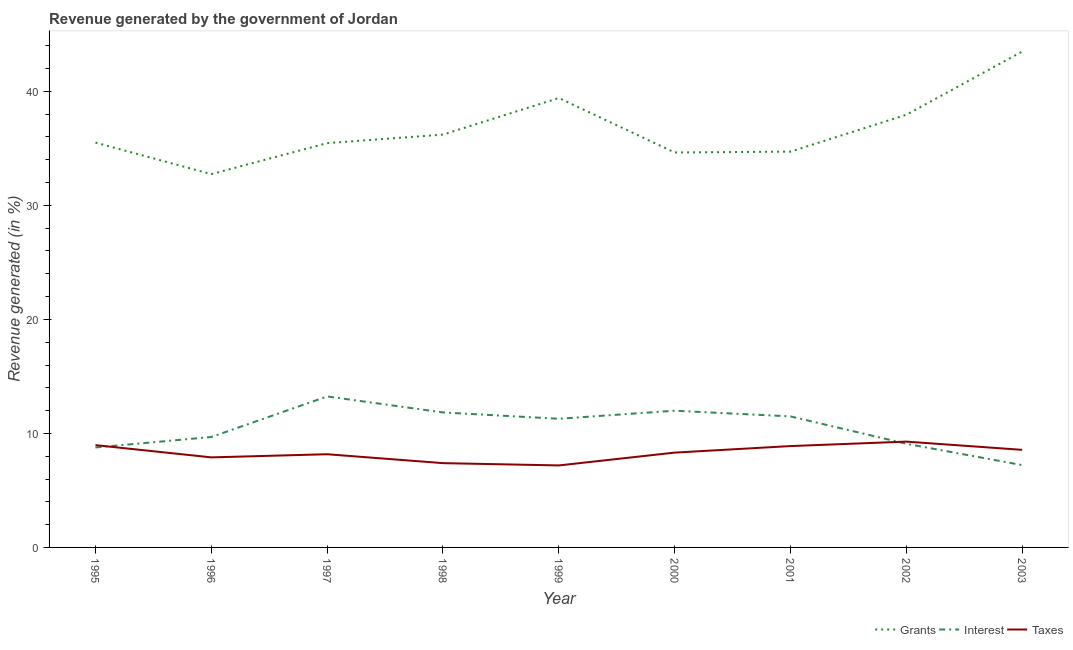What is the percentage of revenue generated by taxes in 1995?
Offer a very short reply. 8.97. Across all years, what is the maximum percentage of revenue generated by grants?
Offer a terse response. 43.49. Across all years, what is the minimum percentage of revenue generated by taxes?
Provide a succinct answer. 7.19. In which year was the percentage of revenue generated by grants maximum?
Offer a terse response. 2003. In which year was the percentage of revenue generated by taxes minimum?
Provide a succinct answer. 1999. What is the total percentage of revenue generated by grants in the graph?
Offer a terse response. 330.13. What is the difference between the percentage of revenue generated by grants in 1996 and that in 2003?
Give a very brief answer. -10.75. What is the difference between the percentage of revenue generated by taxes in 1999 and the percentage of revenue generated by grants in 1995?
Ensure brevity in your answer.  -28.31. What is the average percentage of revenue generated by interest per year?
Ensure brevity in your answer.  10.51. In the year 2001, what is the difference between the percentage of revenue generated by taxes and percentage of revenue generated by grants?
Your answer should be compact. -25.83. In how many years, is the percentage of revenue generated by interest greater than 24 %?
Offer a very short reply. 0. What is the ratio of the percentage of revenue generated by interest in 1998 to that in 2002?
Make the answer very short. 1.3. Is the percentage of revenue generated by interest in 1995 less than that in 1997?
Keep it short and to the point. Yes. What is the difference between the highest and the second highest percentage of revenue generated by interest?
Your response must be concise. 1.25. What is the difference between the highest and the lowest percentage of revenue generated by taxes?
Provide a short and direct response. 2.09. Is it the case that in every year, the sum of the percentage of revenue generated by grants and percentage of revenue generated by interest is greater than the percentage of revenue generated by taxes?
Offer a terse response. Yes. Does the percentage of revenue generated by grants monotonically increase over the years?
Make the answer very short. No. Is the percentage of revenue generated by interest strictly less than the percentage of revenue generated by grants over the years?
Your response must be concise. Yes. What is the difference between two consecutive major ticks on the Y-axis?
Provide a short and direct response. 10. Where does the legend appear in the graph?
Offer a terse response. Bottom right. How are the legend labels stacked?
Keep it short and to the point. Horizontal. What is the title of the graph?
Your response must be concise. Revenue generated by the government of Jordan. What is the label or title of the Y-axis?
Give a very brief answer. Revenue generated (in %). What is the Revenue generated (in %) in Grants in 1995?
Make the answer very short. 35.51. What is the Revenue generated (in %) in Interest in 1995?
Your response must be concise. 8.77. What is the Revenue generated (in %) in Taxes in 1995?
Give a very brief answer. 8.97. What is the Revenue generated (in %) in Grants in 1996?
Your answer should be compact. 32.74. What is the Revenue generated (in %) in Interest in 1996?
Make the answer very short. 9.68. What is the Revenue generated (in %) of Taxes in 1996?
Your answer should be very brief. 7.9. What is the Revenue generated (in %) of Grants in 1997?
Make the answer very short. 35.46. What is the Revenue generated (in %) of Interest in 1997?
Make the answer very short. 13.24. What is the Revenue generated (in %) of Taxes in 1997?
Provide a succinct answer. 8.17. What is the Revenue generated (in %) in Grants in 1998?
Provide a succinct answer. 36.21. What is the Revenue generated (in %) in Interest in 1998?
Keep it short and to the point. 11.84. What is the Revenue generated (in %) of Taxes in 1998?
Make the answer very short. 7.39. What is the Revenue generated (in %) of Grants in 1999?
Provide a succinct answer. 39.42. What is the Revenue generated (in %) of Interest in 1999?
Provide a short and direct response. 11.28. What is the Revenue generated (in %) in Taxes in 1999?
Offer a terse response. 7.19. What is the Revenue generated (in %) in Grants in 2000?
Keep it short and to the point. 34.64. What is the Revenue generated (in %) of Interest in 2000?
Provide a succinct answer. 11.99. What is the Revenue generated (in %) in Taxes in 2000?
Ensure brevity in your answer.  8.32. What is the Revenue generated (in %) in Grants in 2001?
Offer a terse response. 34.71. What is the Revenue generated (in %) in Interest in 2001?
Your answer should be very brief. 11.49. What is the Revenue generated (in %) of Taxes in 2001?
Offer a terse response. 8.89. What is the Revenue generated (in %) in Grants in 2002?
Offer a terse response. 37.95. What is the Revenue generated (in %) in Interest in 2002?
Provide a succinct answer. 9.09. What is the Revenue generated (in %) of Taxes in 2002?
Your answer should be compact. 9.28. What is the Revenue generated (in %) in Grants in 2003?
Your answer should be compact. 43.49. What is the Revenue generated (in %) of Interest in 2003?
Make the answer very short. 7.22. What is the Revenue generated (in %) of Taxes in 2003?
Your answer should be compact. 8.56. Across all years, what is the maximum Revenue generated (in %) in Grants?
Your response must be concise. 43.49. Across all years, what is the maximum Revenue generated (in %) of Interest?
Keep it short and to the point. 13.24. Across all years, what is the maximum Revenue generated (in %) of Taxes?
Your answer should be compact. 9.28. Across all years, what is the minimum Revenue generated (in %) in Grants?
Provide a succinct answer. 32.74. Across all years, what is the minimum Revenue generated (in %) of Interest?
Make the answer very short. 7.22. Across all years, what is the minimum Revenue generated (in %) in Taxes?
Provide a short and direct response. 7.19. What is the total Revenue generated (in %) of Grants in the graph?
Your response must be concise. 330.13. What is the total Revenue generated (in %) of Interest in the graph?
Your answer should be compact. 94.61. What is the total Revenue generated (in %) in Taxes in the graph?
Ensure brevity in your answer.  74.67. What is the difference between the Revenue generated (in %) of Grants in 1995 and that in 1996?
Your answer should be compact. 2.76. What is the difference between the Revenue generated (in %) of Interest in 1995 and that in 1996?
Ensure brevity in your answer.  -0.92. What is the difference between the Revenue generated (in %) in Taxes in 1995 and that in 1996?
Your response must be concise. 1.07. What is the difference between the Revenue generated (in %) in Grants in 1995 and that in 1997?
Your answer should be very brief. 0.05. What is the difference between the Revenue generated (in %) of Interest in 1995 and that in 1997?
Provide a short and direct response. -4.48. What is the difference between the Revenue generated (in %) in Taxes in 1995 and that in 1997?
Keep it short and to the point. 0.8. What is the difference between the Revenue generated (in %) of Grants in 1995 and that in 1998?
Your answer should be very brief. -0.7. What is the difference between the Revenue generated (in %) in Interest in 1995 and that in 1998?
Make the answer very short. -3.07. What is the difference between the Revenue generated (in %) of Taxes in 1995 and that in 1998?
Provide a succinct answer. 1.58. What is the difference between the Revenue generated (in %) in Grants in 1995 and that in 1999?
Your answer should be compact. -3.91. What is the difference between the Revenue generated (in %) in Interest in 1995 and that in 1999?
Provide a succinct answer. -2.52. What is the difference between the Revenue generated (in %) of Taxes in 1995 and that in 1999?
Keep it short and to the point. 1.78. What is the difference between the Revenue generated (in %) in Grants in 1995 and that in 2000?
Give a very brief answer. 0.87. What is the difference between the Revenue generated (in %) of Interest in 1995 and that in 2000?
Give a very brief answer. -3.23. What is the difference between the Revenue generated (in %) of Taxes in 1995 and that in 2000?
Provide a succinct answer. 0.66. What is the difference between the Revenue generated (in %) in Grants in 1995 and that in 2001?
Provide a short and direct response. 0.79. What is the difference between the Revenue generated (in %) in Interest in 1995 and that in 2001?
Your answer should be very brief. -2.73. What is the difference between the Revenue generated (in %) in Taxes in 1995 and that in 2001?
Offer a terse response. 0.08. What is the difference between the Revenue generated (in %) in Grants in 1995 and that in 2002?
Keep it short and to the point. -2.44. What is the difference between the Revenue generated (in %) in Interest in 1995 and that in 2002?
Your answer should be very brief. -0.33. What is the difference between the Revenue generated (in %) of Taxes in 1995 and that in 2002?
Provide a succinct answer. -0.31. What is the difference between the Revenue generated (in %) in Grants in 1995 and that in 2003?
Keep it short and to the point. -7.99. What is the difference between the Revenue generated (in %) in Interest in 1995 and that in 2003?
Give a very brief answer. 1.54. What is the difference between the Revenue generated (in %) of Taxes in 1995 and that in 2003?
Your response must be concise. 0.41. What is the difference between the Revenue generated (in %) of Grants in 1996 and that in 1997?
Ensure brevity in your answer.  -2.72. What is the difference between the Revenue generated (in %) in Interest in 1996 and that in 1997?
Ensure brevity in your answer.  -3.56. What is the difference between the Revenue generated (in %) in Taxes in 1996 and that in 1997?
Provide a short and direct response. -0.28. What is the difference between the Revenue generated (in %) in Grants in 1996 and that in 1998?
Your answer should be compact. -3.47. What is the difference between the Revenue generated (in %) in Interest in 1996 and that in 1998?
Give a very brief answer. -2.15. What is the difference between the Revenue generated (in %) in Taxes in 1996 and that in 1998?
Your answer should be compact. 0.51. What is the difference between the Revenue generated (in %) in Grants in 1996 and that in 1999?
Give a very brief answer. -6.68. What is the difference between the Revenue generated (in %) in Interest in 1996 and that in 1999?
Make the answer very short. -1.6. What is the difference between the Revenue generated (in %) of Taxes in 1996 and that in 1999?
Provide a short and direct response. 0.71. What is the difference between the Revenue generated (in %) in Grants in 1996 and that in 2000?
Offer a very short reply. -1.9. What is the difference between the Revenue generated (in %) in Interest in 1996 and that in 2000?
Ensure brevity in your answer.  -2.31. What is the difference between the Revenue generated (in %) in Taxes in 1996 and that in 2000?
Provide a short and direct response. -0.42. What is the difference between the Revenue generated (in %) in Grants in 1996 and that in 2001?
Your answer should be compact. -1.97. What is the difference between the Revenue generated (in %) in Interest in 1996 and that in 2001?
Your answer should be compact. -1.81. What is the difference between the Revenue generated (in %) in Taxes in 1996 and that in 2001?
Provide a succinct answer. -0.99. What is the difference between the Revenue generated (in %) of Grants in 1996 and that in 2002?
Your answer should be very brief. -5.2. What is the difference between the Revenue generated (in %) of Interest in 1996 and that in 2002?
Your answer should be very brief. 0.59. What is the difference between the Revenue generated (in %) of Taxes in 1996 and that in 2002?
Make the answer very short. -1.38. What is the difference between the Revenue generated (in %) of Grants in 1996 and that in 2003?
Your answer should be very brief. -10.75. What is the difference between the Revenue generated (in %) in Interest in 1996 and that in 2003?
Provide a succinct answer. 2.46. What is the difference between the Revenue generated (in %) in Taxes in 1996 and that in 2003?
Your answer should be compact. -0.66. What is the difference between the Revenue generated (in %) in Grants in 1997 and that in 1998?
Keep it short and to the point. -0.75. What is the difference between the Revenue generated (in %) in Interest in 1997 and that in 1998?
Provide a short and direct response. 1.4. What is the difference between the Revenue generated (in %) in Taxes in 1997 and that in 1998?
Provide a short and direct response. 0.78. What is the difference between the Revenue generated (in %) in Grants in 1997 and that in 1999?
Offer a terse response. -3.96. What is the difference between the Revenue generated (in %) in Interest in 1997 and that in 1999?
Your answer should be very brief. 1.96. What is the difference between the Revenue generated (in %) of Taxes in 1997 and that in 1999?
Your answer should be very brief. 0.98. What is the difference between the Revenue generated (in %) of Grants in 1997 and that in 2000?
Your response must be concise. 0.82. What is the difference between the Revenue generated (in %) of Interest in 1997 and that in 2000?
Provide a succinct answer. 1.25. What is the difference between the Revenue generated (in %) in Taxes in 1997 and that in 2000?
Make the answer very short. -0.14. What is the difference between the Revenue generated (in %) in Grants in 1997 and that in 2001?
Your response must be concise. 0.74. What is the difference between the Revenue generated (in %) in Interest in 1997 and that in 2001?
Ensure brevity in your answer.  1.75. What is the difference between the Revenue generated (in %) in Taxes in 1997 and that in 2001?
Make the answer very short. -0.72. What is the difference between the Revenue generated (in %) of Grants in 1997 and that in 2002?
Offer a terse response. -2.49. What is the difference between the Revenue generated (in %) of Interest in 1997 and that in 2002?
Offer a very short reply. 4.15. What is the difference between the Revenue generated (in %) of Taxes in 1997 and that in 2002?
Keep it short and to the point. -1.11. What is the difference between the Revenue generated (in %) in Grants in 1997 and that in 2003?
Provide a succinct answer. -8.04. What is the difference between the Revenue generated (in %) of Interest in 1997 and that in 2003?
Keep it short and to the point. 6.02. What is the difference between the Revenue generated (in %) of Taxes in 1997 and that in 2003?
Your answer should be compact. -0.38. What is the difference between the Revenue generated (in %) of Grants in 1998 and that in 1999?
Provide a short and direct response. -3.21. What is the difference between the Revenue generated (in %) in Interest in 1998 and that in 1999?
Give a very brief answer. 0.56. What is the difference between the Revenue generated (in %) of Taxes in 1998 and that in 1999?
Provide a succinct answer. 0.2. What is the difference between the Revenue generated (in %) in Grants in 1998 and that in 2000?
Make the answer very short. 1.57. What is the difference between the Revenue generated (in %) of Interest in 1998 and that in 2000?
Offer a terse response. -0.15. What is the difference between the Revenue generated (in %) in Taxes in 1998 and that in 2000?
Your answer should be very brief. -0.92. What is the difference between the Revenue generated (in %) of Grants in 1998 and that in 2001?
Provide a short and direct response. 1.49. What is the difference between the Revenue generated (in %) in Interest in 1998 and that in 2001?
Make the answer very short. 0.35. What is the difference between the Revenue generated (in %) of Taxes in 1998 and that in 2001?
Make the answer very short. -1.5. What is the difference between the Revenue generated (in %) in Grants in 1998 and that in 2002?
Keep it short and to the point. -1.74. What is the difference between the Revenue generated (in %) in Interest in 1998 and that in 2002?
Make the answer very short. 2.75. What is the difference between the Revenue generated (in %) in Taxes in 1998 and that in 2002?
Ensure brevity in your answer.  -1.89. What is the difference between the Revenue generated (in %) of Grants in 1998 and that in 2003?
Provide a short and direct response. -7.29. What is the difference between the Revenue generated (in %) in Interest in 1998 and that in 2003?
Give a very brief answer. 4.62. What is the difference between the Revenue generated (in %) in Taxes in 1998 and that in 2003?
Give a very brief answer. -1.17. What is the difference between the Revenue generated (in %) in Grants in 1999 and that in 2000?
Keep it short and to the point. 4.78. What is the difference between the Revenue generated (in %) of Interest in 1999 and that in 2000?
Your response must be concise. -0.71. What is the difference between the Revenue generated (in %) of Taxes in 1999 and that in 2000?
Your answer should be compact. -1.12. What is the difference between the Revenue generated (in %) in Grants in 1999 and that in 2001?
Offer a very short reply. 4.7. What is the difference between the Revenue generated (in %) in Interest in 1999 and that in 2001?
Your response must be concise. -0.21. What is the difference between the Revenue generated (in %) of Taxes in 1999 and that in 2001?
Provide a short and direct response. -1.7. What is the difference between the Revenue generated (in %) of Grants in 1999 and that in 2002?
Your answer should be very brief. 1.47. What is the difference between the Revenue generated (in %) of Interest in 1999 and that in 2002?
Give a very brief answer. 2.19. What is the difference between the Revenue generated (in %) of Taxes in 1999 and that in 2002?
Provide a short and direct response. -2.09. What is the difference between the Revenue generated (in %) in Grants in 1999 and that in 2003?
Offer a very short reply. -4.08. What is the difference between the Revenue generated (in %) in Interest in 1999 and that in 2003?
Offer a very short reply. 4.06. What is the difference between the Revenue generated (in %) of Taxes in 1999 and that in 2003?
Your answer should be compact. -1.37. What is the difference between the Revenue generated (in %) of Grants in 2000 and that in 2001?
Your answer should be compact. -0.07. What is the difference between the Revenue generated (in %) of Interest in 2000 and that in 2001?
Your answer should be very brief. 0.5. What is the difference between the Revenue generated (in %) of Taxes in 2000 and that in 2001?
Provide a succinct answer. -0.57. What is the difference between the Revenue generated (in %) in Grants in 2000 and that in 2002?
Make the answer very short. -3.31. What is the difference between the Revenue generated (in %) in Interest in 2000 and that in 2002?
Make the answer very short. 2.9. What is the difference between the Revenue generated (in %) of Taxes in 2000 and that in 2002?
Give a very brief answer. -0.96. What is the difference between the Revenue generated (in %) of Grants in 2000 and that in 2003?
Your response must be concise. -8.85. What is the difference between the Revenue generated (in %) in Interest in 2000 and that in 2003?
Your response must be concise. 4.77. What is the difference between the Revenue generated (in %) of Taxes in 2000 and that in 2003?
Your response must be concise. -0.24. What is the difference between the Revenue generated (in %) of Grants in 2001 and that in 2002?
Offer a terse response. -3.23. What is the difference between the Revenue generated (in %) of Interest in 2001 and that in 2002?
Offer a terse response. 2.4. What is the difference between the Revenue generated (in %) of Taxes in 2001 and that in 2002?
Your answer should be compact. -0.39. What is the difference between the Revenue generated (in %) in Grants in 2001 and that in 2003?
Your answer should be compact. -8.78. What is the difference between the Revenue generated (in %) of Interest in 2001 and that in 2003?
Ensure brevity in your answer.  4.27. What is the difference between the Revenue generated (in %) of Taxes in 2001 and that in 2003?
Keep it short and to the point. 0.33. What is the difference between the Revenue generated (in %) in Grants in 2002 and that in 2003?
Keep it short and to the point. -5.55. What is the difference between the Revenue generated (in %) of Interest in 2002 and that in 2003?
Give a very brief answer. 1.87. What is the difference between the Revenue generated (in %) of Taxes in 2002 and that in 2003?
Your answer should be compact. 0.72. What is the difference between the Revenue generated (in %) of Grants in 1995 and the Revenue generated (in %) of Interest in 1996?
Provide a short and direct response. 25.82. What is the difference between the Revenue generated (in %) in Grants in 1995 and the Revenue generated (in %) in Taxes in 1996?
Your answer should be compact. 27.61. What is the difference between the Revenue generated (in %) in Interest in 1995 and the Revenue generated (in %) in Taxes in 1996?
Provide a short and direct response. 0.87. What is the difference between the Revenue generated (in %) in Grants in 1995 and the Revenue generated (in %) in Interest in 1997?
Keep it short and to the point. 22.26. What is the difference between the Revenue generated (in %) in Grants in 1995 and the Revenue generated (in %) in Taxes in 1997?
Make the answer very short. 27.33. What is the difference between the Revenue generated (in %) of Interest in 1995 and the Revenue generated (in %) of Taxes in 1997?
Offer a very short reply. 0.59. What is the difference between the Revenue generated (in %) in Grants in 1995 and the Revenue generated (in %) in Interest in 1998?
Offer a very short reply. 23.67. What is the difference between the Revenue generated (in %) in Grants in 1995 and the Revenue generated (in %) in Taxes in 1998?
Keep it short and to the point. 28.11. What is the difference between the Revenue generated (in %) in Interest in 1995 and the Revenue generated (in %) in Taxes in 1998?
Keep it short and to the point. 1.37. What is the difference between the Revenue generated (in %) in Grants in 1995 and the Revenue generated (in %) in Interest in 1999?
Provide a short and direct response. 24.22. What is the difference between the Revenue generated (in %) in Grants in 1995 and the Revenue generated (in %) in Taxes in 1999?
Keep it short and to the point. 28.31. What is the difference between the Revenue generated (in %) in Interest in 1995 and the Revenue generated (in %) in Taxes in 1999?
Give a very brief answer. 1.57. What is the difference between the Revenue generated (in %) of Grants in 1995 and the Revenue generated (in %) of Interest in 2000?
Your answer should be very brief. 23.52. What is the difference between the Revenue generated (in %) in Grants in 1995 and the Revenue generated (in %) in Taxes in 2000?
Your answer should be compact. 27.19. What is the difference between the Revenue generated (in %) of Interest in 1995 and the Revenue generated (in %) of Taxes in 2000?
Make the answer very short. 0.45. What is the difference between the Revenue generated (in %) of Grants in 1995 and the Revenue generated (in %) of Interest in 2001?
Your response must be concise. 24.01. What is the difference between the Revenue generated (in %) in Grants in 1995 and the Revenue generated (in %) in Taxes in 2001?
Offer a very short reply. 26.62. What is the difference between the Revenue generated (in %) of Interest in 1995 and the Revenue generated (in %) of Taxes in 2001?
Ensure brevity in your answer.  -0.12. What is the difference between the Revenue generated (in %) in Grants in 1995 and the Revenue generated (in %) in Interest in 2002?
Your answer should be compact. 26.42. What is the difference between the Revenue generated (in %) of Grants in 1995 and the Revenue generated (in %) of Taxes in 2002?
Keep it short and to the point. 26.23. What is the difference between the Revenue generated (in %) in Interest in 1995 and the Revenue generated (in %) in Taxes in 2002?
Provide a short and direct response. -0.51. What is the difference between the Revenue generated (in %) in Grants in 1995 and the Revenue generated (in %) in Interest in 2003?
Give a very brief answer. 28.29. What is the difference between the Revenue generated (in %) of Grants in 1995 and the Revenue generated (in %) of Taxes in 2003?
Your answer should be very brief. 26.95. What is the difference between the Revenue generated (in %) in Interest in 1995 and the Revenue generated (in %) in Taxes in 2003?
Give a very brief answer. 0.21. What is the difference between the Revenue generated (in %) of Grants in 1996 and the Revenue generated (in %) of Taxes in 1997?
Your response must be concise. 24.57. What is the difference between the Revenue generated (in %) in Interest in 1996 and the Revenue generated (in %) in Taxes in 1997?
Offer a terse response. 1.51. What is the difference between the Revenue generated (in %) of Grants in 1996 and the Revenue generated (in %) of Interest in 1998?
Ensure brevity in your answer.  20.9. What is the difference between the Revenue generated (in %) in Grants in 1996 and the Revenue generated (in %) in Taxes in 1998?
Keep it short and to the point. 25.35. What is the difference between the Revenue generated (in %) of Interest in 1996 and the Revenue generated (in %) of Taxes in 1998?
Provide a succinct answer. 2.29. What is the difference between the Revenue generated (in %) in Grants in 1996 and the Revenue generated (in %) in Interest in 1999?
Make the answer very short. 21.46. What is the difference between the Revenue generated (in %) in Grants in 1996 and the Revenue generated (in %) in Taxes in 1999?
Make the answer very short. 25.55. What is the difference between the Revenue generated (in %) in Interest in 1996 and the Revenue generated (in %) in Taxes in 1999?
Provide a succinct answer. 2.49. What is the difference between the Revenue generated (in %) in Grants in 1996 and the Revenue generated (in %) in Interest in 2000?
Offer a terse response. 20.75. What is the difference between the Revenue generated (in %) in Grants in 1996 and the Revenue generated (in %) in Taxes in 2000?
Give a very brief answer. 24.43. What is the difference between the Revenue generated (in %) in Interest in 1996 and the Revenue generated (in %) in Taxes in 2000?
Offer a very short reply. 1.37. What is the difference between the Revenue generated (in %) of Grants in 1996 and the Revenue generated (in %) of Interest in 2001?
Provide a short and direct response. 21.25. What is the difference between the Revenue generated (in %) of Grants in 1996 and the Revenue generated (in %) of Taxes in 2001?
Provide a succinct answer. 23.85. What is the difference between the Revenue generated (in %) in Interest in 1996 and the Revenue generated (in %) in Taxes in 2001?
Offer a terse response. 0.8. What is the difference between the Revenue generated (in %) in Grants in 1996 and the Revenue generated (in %) in Interest in 2002?
Give a very brief answer. 23.65. What is the difference between the Revenue generated (in %) of Grants in 1996 and the Revenue generated (in %) of Taxes in 2002?
Offer a terse response. 23.46. What is the difference between the Revenue generated (in %) of Interest in 1996 and the Revenue generated (in %) of Taxes in 2002?
Give a very brief answer. 0.4. What is the difference between the Revenue generated (in %) of Grants in 1996 and the Revenue generated (in %) of Interest in 2003?
Make the answer very short. 25.52. What is the difference between the Revenue generated (in %) in Grants in 1996 and the Revenue generated (in %) in Taxes in 2003?
Your answer should be compact. 24.18. What is the difference between the Revenue generated (in %) of Interest in 1996 and the Revenue generated (in %) of Taxes in 2003?
Your response must be concise. 1.13. What is the difference between the Revenue generated (in %) in Grants in 1997 and the Revenue generated (in %) in Interest in 1998?
Your answer should be compact. 23.62. What is the difference between the Revenue generated (in %) of Grants in 1997 and the Revenue generated (in %) of Taxes in 1998?
Provide a succinct answer. 28.07. What is the difference between the Revenue generated (in %) of Interest in 1997 and the Revenue generated (in %) of Taxes in 1998?
Offer a terse response. 5.85. What is the difference between the Revenue generated (in %) of Grants in 1997 and the Revenue generated (in %) of Interest in 1999?
Provide a succinct answer. 24.17. What is the difference between the Revenue generated (in %) in Grants in 1997 and the Revenue generated (in %) in Taxes in 1999?
Your response must be concise. 28.27. What is the difference between the Revenue generated (in %) of Interest in 1997 and the Revenue generated (in %) of Taxes in 1999?
Your answer should be compact. 6.05. What is the difference between the Revenue generated (in %) of Grants in 1997 and the Revenue generated (in %) of Interest in 2000?
Offer a very short reply. 23.47. What is the difference between the Revenue generated (in %) of Grants in 1997 and the Revenue generated (in %) of Taxes in 2000?
Make the answer very short. 27.14. What is the difference between the Revenue generated (in %) of Interest in 1997 and the Revenue generated (in %) of Taxes in 2000?
Your answer should be very brief. 4.93. What is the difference between the Revenue generated (in %) in Grants in 1997 and the Revenue generated (in %) in Interest in 2001?
Make the answer very short. 23.97. What is the difference between the Revenue generated (in %) of Grants in 1997 and the Revenue generated (in %) of Taxes in 2001?
Your response must be concise. 26.57. What is the difference between the Revenue generated (in %) of Interest in 1997 and the Revenue generated (in %) of Taxes in 2001?
Provide a short and direct response. 4.35. What is the difference between the Revenue generated (in %) in Grants in 1997 and the Revenue generated (in %) in Interest in 2002?
Give a very brief answer. 26.37. What is the difference between the Revenue generated (in %) of Grants in 1997 and the Revenue generated (in %) of Taxes in 2002?
Offer a terse response. 26.18. What is the difference between the Revenue generated (in %) of Interest in 1997 and the Revenue generated (in %) of Taxes in 2002?
Make the answer very short. 3.96. What is the difference between the Revenue generated (in %) in Grants in 1997 and the Revenue generated (in %) in Interest in 2003?
Ensure brevity in your answer.  28.24. What is the difference between the Revenue generated (in %) in Grants in 1997 and the Revenue generated (in %) in Taxes in 2003?
Keep it short and to the point. 26.9. What is the difference between the Revenue generated (in %) of Interest in 1997 and the Revenue generated (in %) of Taxes in 2003?
Give a very brief answer. 4.68. What is the difference between the Revenue generated (in %) in Grants in 1998 and the Revenue generated (in %) in Interest in 1999?
Your response must be concise. 24.92. What is the difference between the Revenue generated (in %) in Grants in 1998 and the Revenue generated (in %) in Taxes in 1999?
Your answer should be compact. 29.02. What is the difference between the Revenue generated (in %) in Interest in 1998 and the Revenue generated (in %) in Taxes in 1999?
Offer a very short reply. 4.65. What is the difference between the Revenue generated (in %) in Grants in 1998 and the Revenue generated (in %) in Interest in 2000?
Your answer should be very brief. 24.22. What is the difference between the Revenue generated (in %) in Grants in 1998 and the Revenue generated (in %) in Taxes in 2000?
Ensure brevity in your answer.  27.89. What is the difference between the Revenue generated (in %) of Interest in 1998 and the Revenue generated (in %) of Taxes in 2000?
Offer a terse response. 3.52. What is the difference between the Revenue generated (in %) in Grants in 1998 and the Revenue generated (in %) in Interest in 2001?
Your answer should be compact. 24.72. What is the difference between the Revenue generated (in %) of Grants in 1998 and the Revenue generated (in %) of Taxes in 2001?
Ensure brevity in your answer.  27.32. What is the difference between the Revenue generated (in %) in Interest in 1998 and the Revenue generated (in %) in Taxes in 2001?
Give a very brief answer. 2.95. What is the difference between the Revenue generated (in %) of Grants in 1998 and the Revenue generated (in %) of Interest in 2002?
Your answer should be very brief. 27.12. What is the difference between the Revenue generated (in %) of Grants in 1998 and the Revenue generated (in %) of Taxes in 2002?
Ensure brevity in your answer.  26.93. What is the difference between the Revenue generated (in %) of Interest in 1998 and the Revenue generated (in %) of Taxes in 2002?
Keep it short and to the point. 2.56. What is the difference between the Revenue generated (in %) in Grants in 1998 and the Revenue generated (in %) in Interest in 2003?
Give a very brief answer. 28.99. What is the difference between the Revenue generated (in %) in Grants in 1998 and the Revenue generated (in %) in Taxes in 2003?
Give a very brief answer. 27.65. What is the difference between the Revenue generated (in %) in Interest in 1998 and the Revenue generated (in %) in Taxes in 2003?
Your response must be concise. 3.28. What is the difference between the Revenue generated (in %) in Grants in 1999 and the Revenue generated (in %) in Interest in 2000?
Keep it short and to the point. 27.43. What is the difference between the Revenue generated (in %) in Grants in 1999 and the Revenue generated (in %) in Taxes in 2000?
Ensure brevity in your answer.  31.1. What is the difference between the Revenue generated (in %) in Interest in 1999 and the Revenue generated (in %) in Taxes in 2000?
Provide a short and direct response. 2.97. What is the difference between the Revenue generated (in %) of Grants in 1999 and the Revenue generated (in %) of Interest in 2001?
Provide a short and direct response. 27.93. What is the difference between the Revenue generated (in %) in Grants in 1999 and the Revenue generated (in %) in Taxes in 2001?
Provide a short and direct response. 30.53. What is the difference between the Revenue generated (in %) in Interest in 1999 and the Revenue generated (in %) in Taxes in 2001?
Your response must be concise. 2.39. What is the difference between the Revenue generated (in %) in Grants in 1999 and the Revenue generated (in %) in Interest in 2002?
Offer a very short reply. 30.33. What is the difference between the Revenue generated (in %) in Grants in 1999 and the Revenue generated (in %) in Taxes in 2002?
Your answer should be compact. 30.14. What is the difference between the Revenue generated (in %) in Interest in 1999 and the Revenue generated (in %) in Taxes in 2002?
Offer a terse response. 2. What is the difference between the Revenue generated (in %) in Grants in 1999 and the Revenue generated (in %) in Interest in 2003?
Provide a short and direct response. 32.2. What is the difference between the Revenue generated (in %) in Grants in 1999 and the Revenue generated (in %) in Taxes in 2003?
Ensure brevity in your answer.  30.86. What is the difference between the Revenue generated (in %) of Interest in 1999 and the Revenue generated (in %) of Taxes in 2003?
Your response must be concise. 2.73. What is the difference between the Revenue generated (in %) in Grants in 2000 and the Revenue generated (in %) in Interest in 2001?
Provide a succinct answer. 23.15. What is the difference between the Revenue generated (in %) in Grants in 2000 and the Revenue generated (in %) in Taxes in 2001?
Provide a succinct answer. 25.75. What is the difference between the Revenue generated (in %) in Interest in 2000 and the Revenue generated (in %) in Taxes in 2001?
Provide a succinct answer. 3.1. What is the difference between the Revenue generated (in %) of Grants in 2000 and the Revenue generated (in %) of Interest in 2002?
Provide a succinct answer. 25.55. What is the difference between the Revenue generated (in %) in Grants in 2000 and the Revenue generated (in %) in Taxes in 2002?
Your answer should be very brief. 25.36. What is the difference between the Revenue generated (in %) of Interest in 2000 and the Revenue generated (in %) of Taxes in 2002?
Offer a terse response. 2.71. What is the difference between the Revenue generated (in %) in Grants in 2000 and the Revenue generated (in %) in Interest in 2003?
Keep it short and to the point. 27.42. What is the difference between the Revenue generated (in %) in Grants in 2000 and the Revenue generated (in %) in Taxes in 2003?
Your answer should be compact. 26.08. What is the difference between the Revenue generated (in %) in Interest in 2000 and the Revenue generated (in %) in Taxes in 2003?
Ensure brevity in your answer.  3.43. What is the difference between the Revenue generated (in %) in Grants in 2001 and the Revenue generated (in %) in Interest in 2002?
Offer a very short reply. 25.62. What is the difference between the Revenue generated (in %) in Grants in 2001 and the Revenue generated (in %) in Taxes in 2002?
Provide a succinct answer. 25.43. What is the difference between the Revenue generated (in %) of Interest in 2001 and the Revenue generated (in %) of Taxes in 2002?
Keep it short and to the point. 2.21. What is the difference between the Revenue generated (in %) of Grants in 2001 and the Revenue generated (in %) of Interest in 2003?
Offer a very short reply. 27.49. What is the difference between the Revenue generated (in %) of Grants in 2001 and the Revenue generated (in %) of Taxes in 2003?
Provide a succinct answer. 26.16. What is the difference between the Revenue generated (in %) in Interest in 2001 and the Revenue generated (in %) in Taxes in 2003?
Offer a terse response. 2.93. What is the difference between the Revenue generated (in %) in Grants in 2002 and the Revenue generated (in %) in Interest in 2003?
Give a very brief answer. 30.73. What is the difference between the Revenue generated (in %) in Grants in 2002 and the Revenue generated (in %) in Taxes in 2003?
Your answer should be compact. 29.39. What is the difference between the Revenue generated (in %) of Interest in 2002 and the Revenue generated (in %) of Taxes in 2003?
Offer a terse response. 0.53. What is the average Revenue generated (in %) in Grants per year?
Offer a terse response. 36.68. What is the average Revenue generated (in %) of Interest per year?
Your answer should be compact. 10.51. What is the average Revenue generated (in %) in Taxes per year?
Offer a terse response. 8.3. In the year 1995, what is the difference between the Revenue generated (in %) in Grants and Revenue generated (in %) in Interest?
Your answer should be compact. 26.74. In the year 1995, what is the difference between the Revenue generated (in %) of Grants and Revenue generated (in %) of Taxes?
Offer a very short reply. 26.54. In the year 1995, what is the difference between the Revenue generated (in %) of Interest and Revenue generated (in %) of Taxes?
Your response must be concise. -0.21. In the year 1996, what is the difference between the Revenue generated (in %) of Grants and Revenue generated (in %) of Interest?
Your answer should be very brief. 23.06. In the year 1996, what is the difference between the Revenue generated (in %) of Grants and Revenue generated (in %) of Taxes?
Give a very brief answer. 24.84. In the year 1996, what is the difference between the Revenue generated (in %) of Interest and Revenue generated (in %) of Taxes?
Your response must be concise. 1.79. In the year 1997, what is the difference between the Revenue generated (in %) of Grants and Revenue generated (in %) of Interest?
Provide a succinct answer. 22.22. In the year 1997, what is the difference between the Revenue generated (in %) in Grants and Revenue generated (in %) in Taxes?
Offer a terse response. 27.28. In the year 1997, what is the difference between the Revenue generated (in %) in Interest and Revenue generated (in %) in Taxes?
Your answer should be very brief. 5.07. In the year 1998, what is the difference between the Revenue generated (in %) in Grants and Revenue generated (in %) in Interest?
Keep it short and to the point. 24.37. In the year 1998, what is the difference between the Revenue generated (in %) of Grants and Revenue generated (in %) of Taxes?
Keep it short and to the point. 28.82. In the year 1998, what is the difference between the Revenue generated (in %) in Interest and Revenue generated (in %) in Taxes?
Your response must be concise. 4.45. In the year 1999, what is the difference between the Revenue generated (in %) in Grants and Revenue generated (in %) in Interest?
Offer a terse response. 28.13. In the year 1999, what is the difference between the Revenue generated (in %) in Grants and Revenue generated (in %) in Taxes?
Offer a terse response. 32.23. In the year 1999, what is the difference between the Revenue generated (in %) of Interest and Revenue generated (in %) of Taxes?
Give a very brief answer. 4.09. In the year 2000, what is the difference between the Revenue generated (in %) in Grants and Revenue generated (in %) in Interest?
Provide a succinct answer. 22.65. In the year 2000, what is the difference between the Revenue generated (in %) in Grants and Revenue generated (in %) in Taxes?
Keep it short and to the point. 26.32. In the year 2000, what is the difference between the Revenue generated (in %) of Interest and Revenue generated (in %) of Taxes?
Keep it short and to the point. 3.68. In the year 2001, what is the difference between the Revenue generated (in %) of Grants and Revenue generated (in %) of Interest?
Offer a very short reply. 23.22. In the year 2001, what is the difference between the Revenue generated (in %) of Grants and Revenue generated (in %) of Taxes?
Offer a terse response. 25.83. In the year 2001, what is the difference between the Revenue generated (in %) of Interest and Revenue generated (in %) of Taxes?
Offer a very short reply. 2.6. In the year 2002, what is the difference between the Revenue generated (in %) in Grants and Revenue generated (in %) in Interest?
Offer a terse response. 28.86. In the year 2002, what is the difference between the Revenue generated (in %) of Grants and Revenue generated (in %) of Taxes?
Your answer should be compact. 28.67. In the year 2002, what is the difference between the Revenue generated (in %) in Interest and Revenue generated (in %) in Taxes?
Ensure brevity in your answer.  -0.19. In the year 2003, what is the difference between the Revenue generated (in %) in Grants and Revenue generated (in %) in Interest?
Provide a succinct answer. 36.27. In the year 2003, what is the difference between the Revenue generated (in %) of Grants and Revenue generated (in %) of Taxes?
Your answer should be compact. 34.94. In the year 2003, what is the difference between the Revenue generated (in %) in Interest and Revenue generated (in %) in Taxes?
Give a very brief answer. -1.34. What is the ratio of the Revenue generated (in %) in Grants in 1995 to that in 1996?
Offer a terse response. 1.08. What is the ratio of the Revenue generated (in %) in Interest in 1995 to that in 1996?
Provide a succinct answer. 0.91. What is the ratio of the Revenue generated (in %) in Taxes in 1995 to that in 1996?
Your answer should be compact. 1.14. What is the ratio of the Revenue generated (in %) of Grants in 1995 to that in 1997?
Give a very brief answer. 1. What is the ratio of the Revenue generated (in %) of Interest in 1995 to that in 1997?
Provide a succinct answer. 0.66. What is the ratio of the Revenue generated (in %) in Taxes in 1995 to that in 1997?
Keep it short and to the point. 1.1. What is the ratio of the Revenue generated (in %) in Grants in 1995 to that in 1998?
Give a very brief answer. 0.98. What is the ratio of the Revenue generated (in %) of Interest in 1995 to that in 1998?
Your answer should be very brief. 0.74. What is the ratio of the Revenue generated (in %) of Taxes in 1995 to that in 1998?
Make the answer very short. 1.21. What is the ratio of the Revenue generated (in %) of Grants in 1995 to that in 1999?
Keep it short and to the point. 0.9. What is the ratio of the Revenue generated (in %) in Interest in 1995 to that in 1999?
Provide a succinct answer. 0.78. What is the ratio of the Revenue generated (in %) in Taxes in 1995 to that in 1999?
Give a very brief answer. 1.25. What is the ratio of the Revenue generated (in %) in Interest in 1995 to that in 2000?
Your response must be concise. 0.73. What is the ratio of the Revenue generated (in %) of Taxes in 1995 to that in 2000?
Offer a very short reply. 1.08. What is the ratio of the Revenue generated (in %) in Grants in 1995 to that in 2001?
Your response must be concise. 1.02. What is the ratio of the Revenue generated (in %) in Interest in 1995 to that in 2001?
Make the answer very short. 0.76. What is the ratio of the Revenue generated (in %) of Taxes in 1995 to that in 2001?
Ensure brevity in your answer.  1.01. What is the ratio of the Revenue generated (in %) in Grants in 1995 to that in 2002?
Offer a terse response. 0.94. What is the ratio of the Revenue generated (in %) in Interest in 1995 to that in 2002?
Give a very brief answer. 0.96. What is the ratio of the Revenue generated (in %) in Taxes in 1995 to that in 2002?
Provide a short and direct response. 0.97. What is the ratio of the Revenue generated (in %) of Grants in 1995 to that in 2003?
Ensure brevity in your answer.  0.82. What is the ratio of the Revenue generated (in %) of Interest in 1995 to that in 2003?
Keep it short and to the point. 1.21. What is the ratio of the Revenue generated (in %) in Taxes in 1995 to that in 2003?
Keep it short and to the point. 1.05. What is the ratio of the Revenue generated (in %) in Grants in 1996 to that in 1997?
Keep it short and to the point. 0.92. What is the ratio of the Revenue generated (in %) in Interest in 1996 to that in 1997?
Your answer should be very brief. 0.73. What is the ratio of the Revenue generated (in %) in Taxes in 1996 to that in 1997?
Give a very brief answer. 0.97. What is the ratio of the Revenue generated (in %) in Grants in 1996 to that in 1998?
Offer a terse response. 0.9. What is the ratio of the Revenue generated (in %) of Interest in 1996 to that in 1998?
Give a very brief answer. 0.82. What is the ratio of the Revenue generated (in %) of Taxes in 1996 to that in 1998?
Your response must be concise. 1.07. What is the ratio of the Revenue generated (in %) of Grants in 1996 to that in 1999?
Your response must be concise. 0.83. What is the ratio of the Revenue generated (in %) in Interest in 1996 to that in 1999?
Your answer should be very brief. 0.86. What is the ratio of the Revenue generated (in %) in Taxes in 1996 to that in 1999?
Your response must be concise. 1.1. What is the ratio of the Revenue generated (in %) of Grants in 1996 to that in 2000?
Your answer should be compact. 0.95. What is the ratio of the Revenue generated (in %) in Interest in 1996 to that in 2000?
Offer a terse response. 0.81. What is the ratio of the Revenue generated (in %) of Taxes in 1996 to that in 2000?
Make the answer very short. 0.95. What is the ratio of the Revenue generated (in %) of Grants in 1996 to that in 2001?
Ensure brevity in your answer.  0.94. What is the ratio of the Revenue generated (in %) of Interest in 1996 to that in 2001?
Your response must be concise. 0.84. What is the ratio of the Revenue generated (in %) in Taxes in 1996 to that in 2001?
Offer a terse response. 0.89. What is the ratio of the Revenue generated (in %) in Grants in 1996 to that in 2002?
Offer a very short reply. 0.86. What is the ratio of the Revenue generated (in %) of Interest in 1996 to that in 2002?
Offer a terse response. 1.07. What is the ratio of the Revenue generated (in %) of Taxes in 1996 to that in 2002?
Make the answer very short. 0.85. What is the ratio of the Revenue generated (in %) of Grants in 1996 to that in 2003?
Offer a terse response. 0.75. What is the ratio of the Revenue generated (in %) in Interest in 1996 to that in 2003?
Provide a succinct answer. 1.34. What is the ratio of the Revenue generated (in %) in Taxes in 1996 to that in 2003?
Keep it short and to the point. 0.92. What is the ratio of the Revenue generated (in %) in Grants in 1997 to that in 1998?
Keep it short and to the point. 0.98. What is the ratio of the Revenue generated (in %) of Interest in 1997 to that in 1998?
Give a very brief answer. 1.12. What is the ratio of the Revenue generated (in %) of Taxes in 1997 to that in 1998?
Keep it short and to the point. 1.11. What is the ratio of the Revenue generated (in %) in Grants in 1997 to that in 1999?
Make the answer very short. 0.9. What is the ratio of the Revenue generated (in %) in Interest in 1997 to that in 1999?
Ensure brevity in your answer.  1.17. What is the ratio of the Revenue generated (in %) of Taxes in 1997 to that in 1999?
Provide a short and direct response. 1.14. What is the ratio of the Revenue generated (in %) of Grants in 1997 to that in 2000?
Give a very brief answer. 1.02. What is the ratio of the Revenue generated (in %) of Interest in 1997 to that in 2000?
Give a very brief answer. 1.1. What is the ratio of the Revenue generated (in %) of Taxes in 1997 to that in 2000?
Keep it short and to the point. 0.98. What is the ratio of the Revenue generated (in %) in Grants in 1997 to that in 2001?
Your answer should be compact. 1.02. What is the ratio of the Revenue generated (in %) of Interest in 1997 to that in 2001?
Your answer should be compact. 1.15. What is the ratio of the Revenue generated (in %) of Taxes in 1997 to that in 2001?
Make the answer very short. 0.92. What is the ratio of the Revenue generated (in %) of Grants in 1997 to that in 2002?
Make the answer very short. 0.93. What is the ratio of the Revenue generated (in %) in Interest in 1997 to that in 2002?
Your answer should be compact. 1.46. What is the ratio of the Revenue generated (in %) of Taxes in 1997 to that in 2002?
Your answer should be compact. 0.88. What is the ratio of the Revenue generated (in %) of Grants in 1997 to that in 2003?
Offer a very short reply. 0.82. What is the ratio of the Revenue generated (in %) in Interest in 1997 to that in 2003?
Your answer should be compact. 1.83. What is the ratio of the Revenue generated (in %) in Taxes in 1997 to that in 2003?
Give a very brief answer. 0.96. What is the ratio of the Revenue generated (in %) of Grants in 1998 to that in 1999?
Your response must be concise. 0.92. What is the ratio of the Revenue generated (in %) in Interest in 1998 to that in 1999?
Ensure brevity in your answer.  1.05. What is the ratio of the Revenue generated (in %) in Taxes in 1998 to that in 1999?
Your answer should be compact. 1.03. What is the ratio of the Revenue generated (in %) in Grants in 1998 to that in 2000?
Your answer should be compact. 1.05. What is the ratio of the Revenue generated (in %) in Interest in 1998 to that in 2000?
Provide a succinct answer. 0.99. What is the ratio of the Revenue generated (in %) of Taxes in 1998 to that in 2000?
Provide a succinct answer. 0.89. What is the ratio of the Revenue generated (in %) of Grants in 1998 to that in 2001?
Provide a short and direct response. 1.04. What is the ratio of the Revenue generated (in %) in Interest in 1998 to that in 2001?
Give a very brief answer. 1.03. What is the ratio of the Revenue generated (in %) in Taxes in 1998 to that in 2001?
Your answer should be compact. 0.83. What is the ratio of the Revenue generated (in %) in Grants in 1998 to that in 2002?
Offer a very short reply. 0.95. What is the ratio of the Revenue generated (in %) in Interest in 1998 to that in 2002?
Your answer should be compact. 1.3. What is the ratio of the Revenue generated (in %) in Taxes in 1998 to that in 2002?
Offer a terse response. 0.8. What is the ratio of the Revenue generated (in %) of Grants in 1998 to that in 2003?
Offer a very short reply. 0.83. What is the ratio of the Revenue generated (in %) in Interest in 1998 to that in 2003?
Keep it short and to the point. 1.64. What is the ratio of the Revenue generated (in %) of Taxes in 1998 to that in 2003?
Offer a terse response. 0.86. What is the ratio of the Revenue generated (in %) in Grants in 1999 to that in 2000?
Your answer should be compact. 1.14. What is the ratio of the Revenue generated (in %) in Interest in 1999 to that in 2000?
Ensure brevity in your answer.  0.94. What is the ratio of the Revenue generated (in %) of Taxes in 1999 to that in 2000?
Your answer should be compact. 0.86. What is the ratio of the Revenue generated (in %) in Grants in 1999 to that in 2001?
Offer a very short reply. 1.14. What is the ratio of the Revenue generated (in %) in Interest in 1999 to that in 2001?
Give a very brief answer. 0.98. What is the ratio of the Revenue generated (in %) of Taxes in 1999 to that in 2001?
Your answer should be very brief. 0.81. What is the ratio of the Revenue generated (in %) of Grants in 1999 to that in 2002?
Your response must be concise. 1.04. What is the ratio of the Revenue generated (in %) of Interest in 1999 to that in 2002?
Offer a very short reply. 1.24. What is the ratio of the Revenue generated (in %) in Taxes in 1999 to that in 2002?
Provide a short and direct response. 0.78. What is the ratio of the Revenue generated (in %) of Grants in 1999 to that in 2003?
Your answer should be very brief. 0.91. What is the ratio of the Revenue generated (in %) in Interest in 1999 to that in 2003?
Make the answer very short. 1.56. What is the ratio of the Revenue generated (in %) in Taxes in 1999 to that in 2003?
Make the answer very short. 0.84. What is the ratio of the Revenue generated (in %) of Interest in 2000 to that in 2001?
Offer a terse response. 1.04. What is the ratio of the Revenue generated (in %) of Taxes in 2000 to that in 2001?
Your answer should be compact. 0.94. What is the ratio of the Revenue generated (in %) of Grants in 2000 to that in 2002?
Offer a terse response. 0.91. What is the ratio of the Revenue generated (in %) of Interest in 2000 to that in 2002?
Make the answer very short. 1.32. What is the ratio of the Revenue generated (in %) in Taxes in 2000 to that in 2002?
Offer a very short reply. 0.9. What is the ratio of the Revenue generated (in %) in Grants in 2000 to that in 2003?
Your response must be concise. 0.8. What is the ratio of the Revenue generated (in %) of Interest in 2000 to that in 2003?
Provide a succinct answer. 1.66. What is the ratio of the Revenue generated (in %) of Taxes in 2000 to that in 2003?
Provide a short and direct response. 0.97. What is the ratio of the Revenue generated (in %) of Grants in 2001 to that in 2002?
Your answer should be very brief. 0.91. What is the ratio of the Revenue generated (in %) of Interest in 2001 to that in 2002?
Offer a very short reply. 1.26. What is the ratio of the Revenue generated (in %) in Taxes in 2001 to that in 2002?
Your answer should be very brief. 0.96. What is the ratio of the Revenue generated (in %) in Grants in 2001 to that in 2003?
Your answer should be very brief. 0.8. What is the ratio of the Revenue generated (in %) in Interest in 2001 to that in 2003?
Ensure brevity in your answer.  1.59. What is the ratio of the Revenue generated (in %) in Taxes in 2001 to that in 2003?
Make the answer very short. 1.04. What is the ratio of the Revenue generated (in %) in Grants in 2002 to that in 2003?
Give a very brief answer. 0.87. What is the ratio of the Revenue generated (in %) of Interest in 2002 to that in 2003?
Give a very brief answer. 1.26. What is the ratio of the Revenue generated (in %) in Taxes in 2002 to that in 2003?
Your answer should be compact. 1.08. What is the difference between the highest and the second highest Revenue generated (in %) of Grants?
Provide a succinct answer. 4.08. What is the difference between the highest and the second highest Revenue generated (in %) of Interest?
Make the answer very short. 1.25. What is the difference between the highest and the second highest Revenue generated (in %) of Taxes?
Keep it short and to the point. 0.31. What is the difference between the highest and the lowest Revenue generated (in %) in Grants?
Provide a short and direct response. 10.75. What is the difference between the highest and the lowest Revenue generated (in %) in Interest?
Your answer should be very brief. 6.02. What is the difference between the highest and the lowest Revenue generated (in %) in Taxes?
Provide a short and direct response. 2.09. 